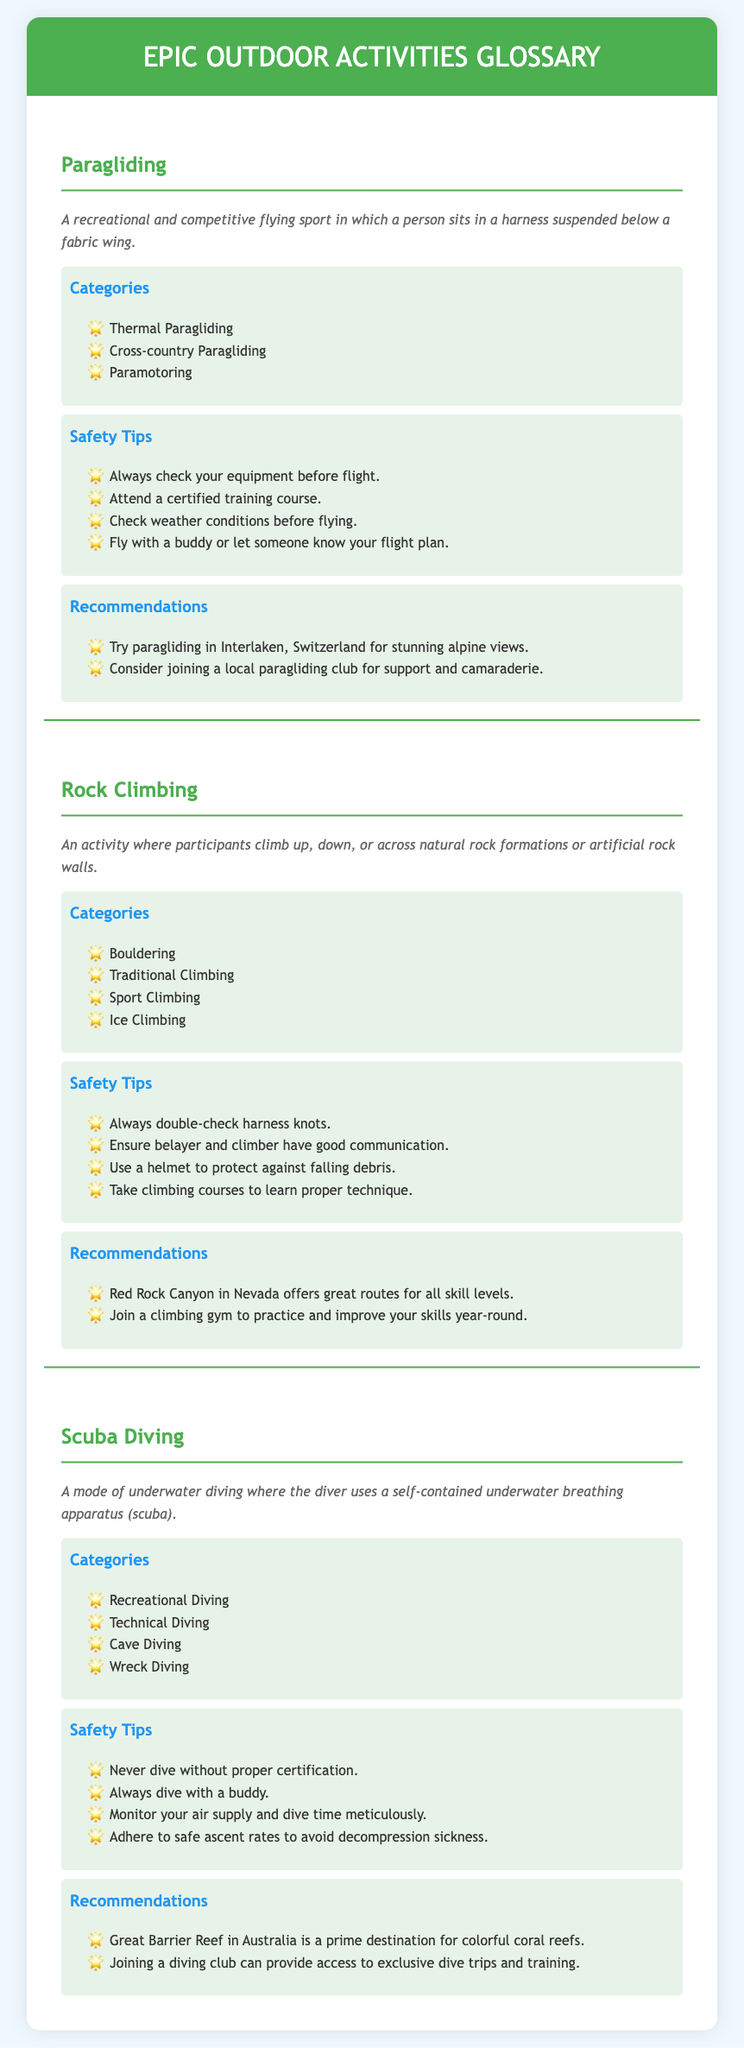What is paragliding? Paragliding is defined as a recreational and competitive flying sport in which a person sits in a harness suspended below a fabric wing.
Answer: A recreational and competitive flying sport What are the categories of rock climbing? The document lists four categories of rock climbing, which include Boulder, Traditional Climbing, Sport Climbing, and Ice Climbing.
Answer: Bouldering, Traditional Climbing, Sport Climbing, Ice Climbing What is a safety tip for scuba diving? A safety tip for scuba diving from the document states never dive without proper certification.
Answer: Never dive without proper certification How many recommendations are given for paragliding? The document provides two recommendations specifically for paragliding activities.
Answer: Two Which location is recommended for scuba diving? The Great Barrier Reef in Australia is mentioned as a prime destination for scuba diving.
Answer: Great Barrier Reef in Australia What should you do before flying when paragliding? Before flying when paragliding, one should check weather conditions.
Answer: Check weather conditions What equipment is essential for rock climbing? The document emphasizes the importance of a helmet for protection against falling debris while rock climbing.
Answer: Helmet What type of diving is cave diving categorized as? Cave diving is categorized under technical diving in the scuba diving section of the document.
Answer: Technical Diving 